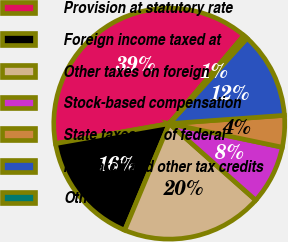<chart> <loc_0><loc_0><loc_500><loc_500><pie_chart><fcel>Provision at statutory rate<fcel>Foreign income taxed at<fcel>Other taxes on foreign<fcel>Stock-based compensation<fcel>State taxes net of federal<fcel>Research and other tax credits<fcel>Other<nl><fcel>38.94%<fcel>15.93%<fcel>19.77%<fcel>8.26%<fcel>4.42%<fcel>12.09%<fcel>0.59%<nl></chart> 